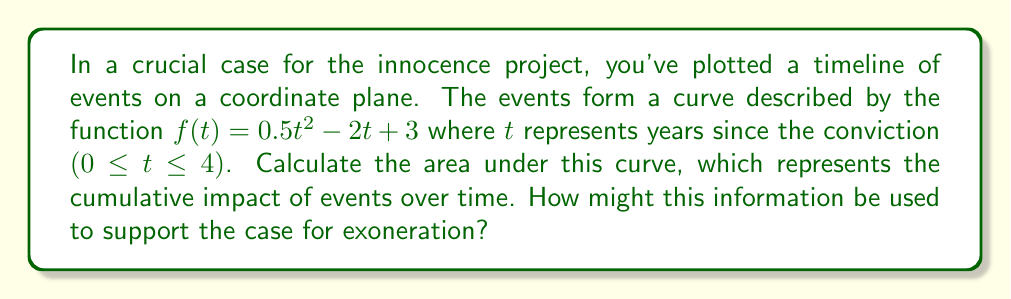Can you solve this math problem? To calculate the area under the curve, we need to integrate the function $f(t)$ from $t=0$ to $t=4$. Here's the step-by-step process:

1) The function is $f(t) = 0.5t^2 - 2t + 3$

2) We need to find $\int_0^4 f(t) dt$

3) Integrate each term:
   $$\int_0^4 (0.5t^2 - 2t + 3) dt = [\frac{0.5t^3}{3} - t^2 + 3t]_0^4$$

4) Evaluate the integral:
   $$= (\frac{0.5(4^3)}{3} - 4^2 + 3(4)) - (\frac{0.5(0^3)}{3} - 0^2 + 3(0))$$
   $$= (\frac{32}{3} - 16 + 12) - (0)$$
   $$= \frac{32}{3} - 4$$
   $$= \frac{20}{3}$$

5) The area under the curve is $\frac{20}{3}$ square units.

This result represents the cumulative impact of events over the 4-year period. A larger area might indicate a higher density of significant events or developments in the case. This quantitative analysis could be used to demonstrate the complexity of the case or the volume of new evidence that has emerged since the conviction, potentially supporting the argument for exoneration.
Answer: $\frac{20}{3}$ square units 